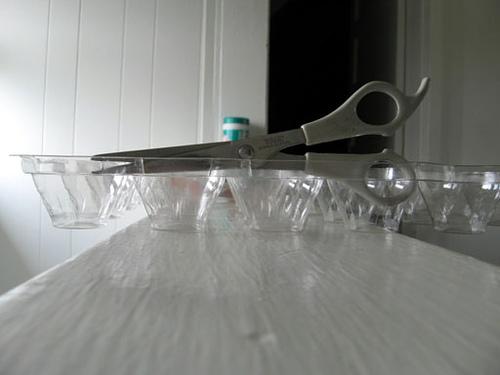Do you see any cleaning wipes in the photo?
Answer briefly. Yes. What is the sharp object seen in the photo?
Be succinct. Scissors. Are the items in this photo clean?
Short answer required. Yes. 